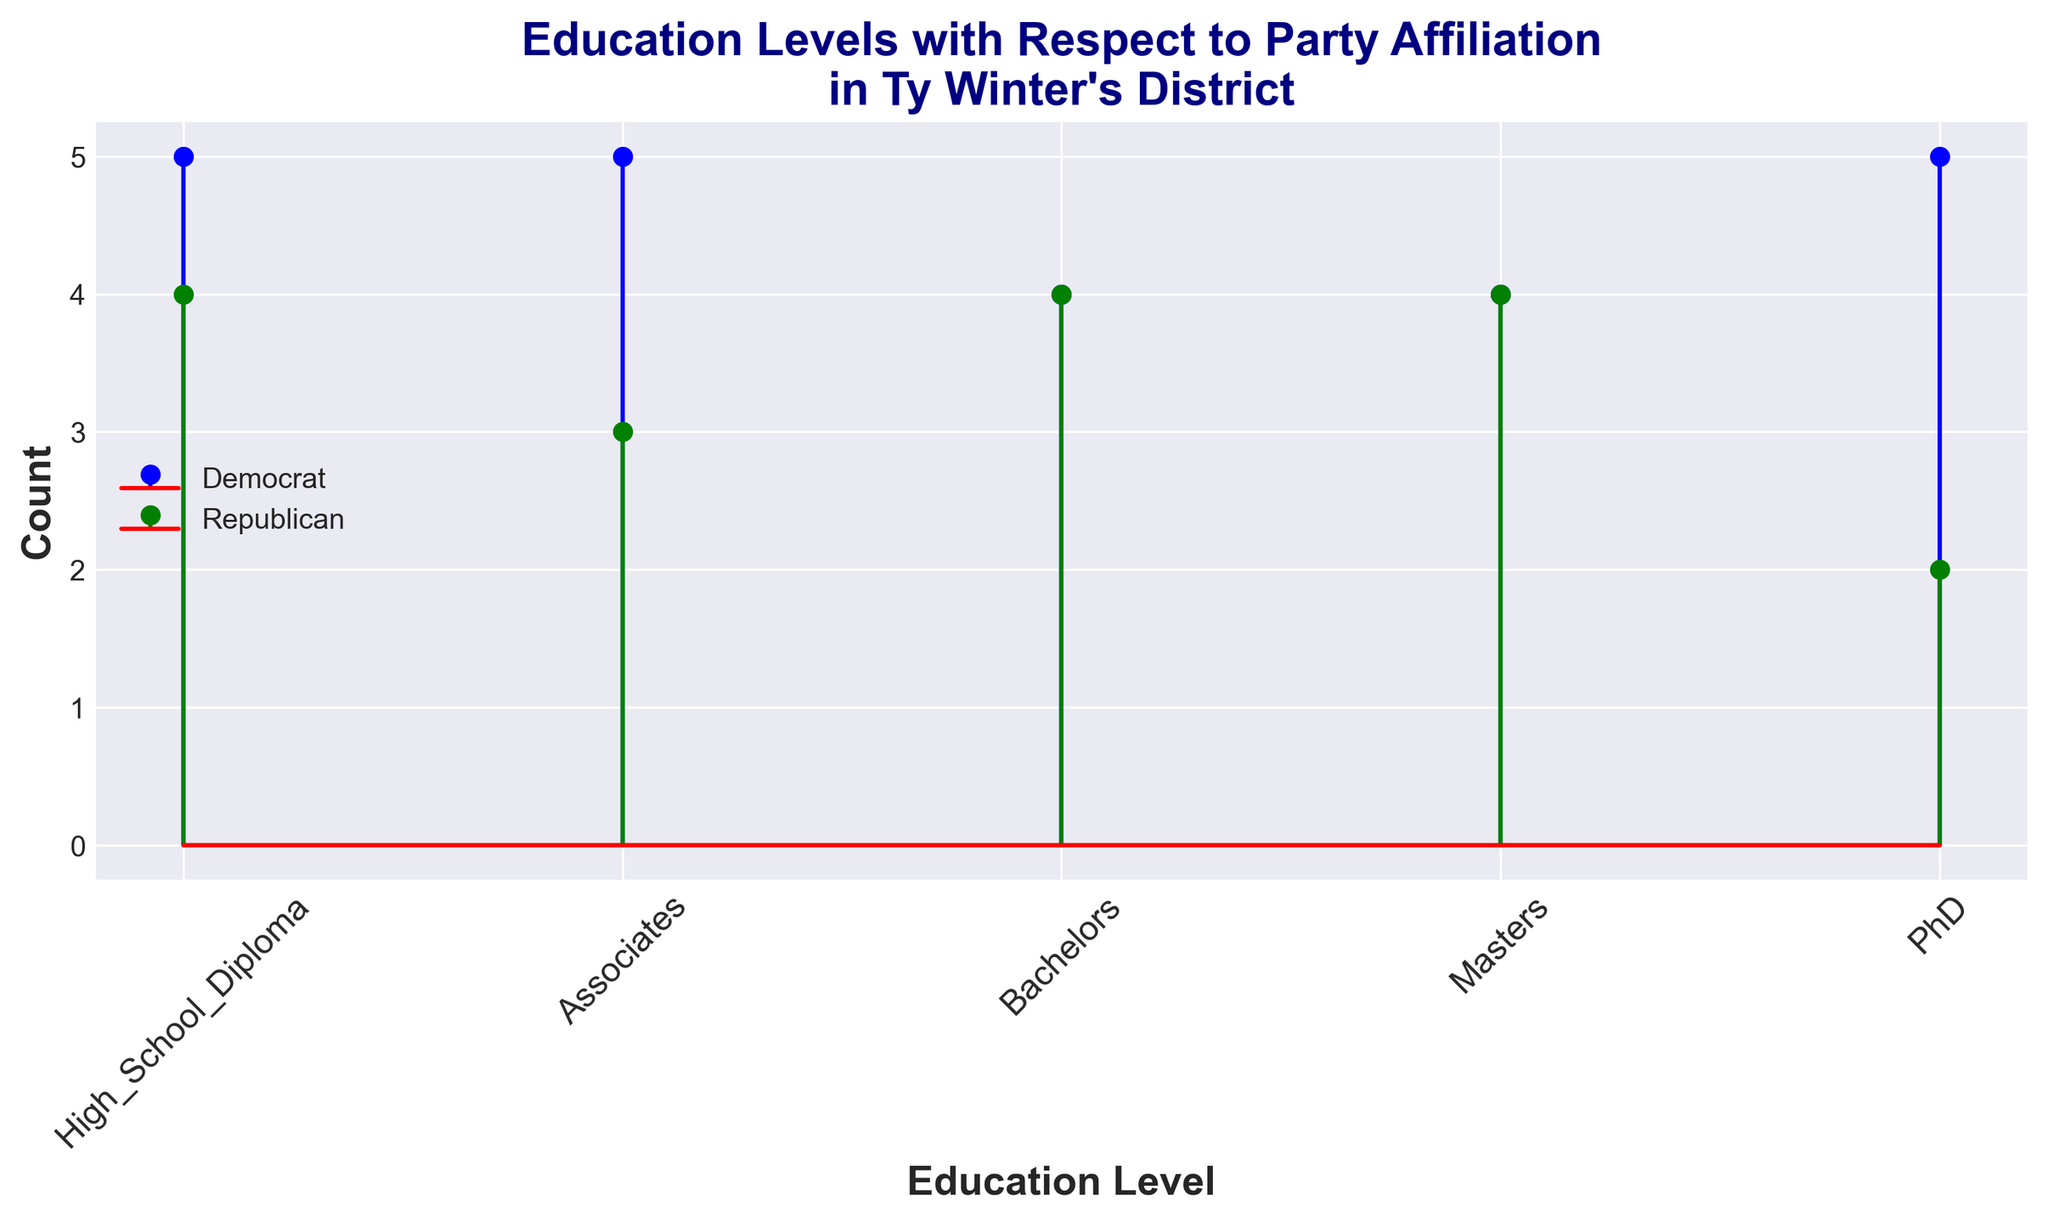Which educational level has the highest number of Democrats? By examining the heights of the blue stems, we see that "High_School_Diploma" has the tallest blue stem, indicating the highest number of Democrats in this category.
Answer: High School Diploma How many more Democrats than Republicans have a Master's degree? By comparing the height of the blue stem (Democrats) with the green stem (Republicans) for the "Masters" category, we see there are 6 Democrats and 4 Republicans. Therefore, the difference is 6 - 4 = 2.
Answer: 2 Which group has more PhD holders, Democrats or Republicans? By comparing the blue and green stems for the "PhD" category, the blue stem (Democrats) is taller with 5 compared to the green stem (Republicans) with 2.
Answer: Democrats What is the total number of people with an Associate degree? By summing the blue and green stems for the "Associates" category, there are 6 Democrats and 4 Republicans which totals 6 + 4 = 10.
Answer: 10 Is there any educational level where the number of Democrats and Republicans is equal? Reviewing each category's stems, there is no category where the blue and green stems are of equal height. Hence, the counts are unequal in all categories.
Answer: No 